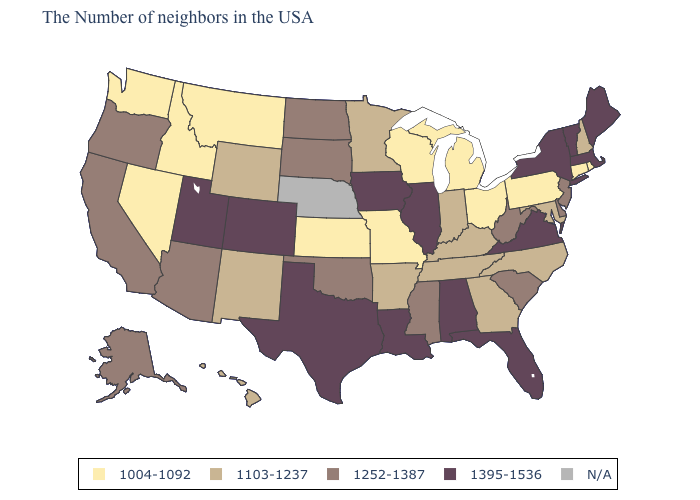What is the highest value in states that border New Jersey?
Concise answer only. 1395-1536. What is the value of Georgia?
Keep it brief. 1103-1237. What is the highest value in the USA?
Give a very brief answer. 1395-1536. What is the value of Pennsylvania?
Quick response, please. 1004-1092. What is the lowest value in states that border Tennessee?
Give a very brief answer. 1004-1092. What is the lowest value in the USA?
Write a very short answer. 1004-1092. Name the states that have a value in the range 1395-1536?
Write a very short answer. Maine, Massachusetts, Vermont, New York, Virginia, Florida, Alabama, Illinois, Louisiana, Iowa, Texas, Colorado, Utah. Which states hav the highest value in the West?
Quick response, please. Colorado, Utah. What is the value of Wyoming?
Short answer required. 1103-1237. What is the highest value in states that border Vermont?
Short answer required. 1395-1536. What is the value of Connecticut?
Give a very brief answer. 1004-1092. Name the states that have a value in the range 1103-1237?
Be succinct. New Hampshire, Maryland, North Carolina, Georgia, Kentucky, Indiana, Tennessee, Arkansas, Minnesota, Wyoming, New Mexico, Hawaii. What is the value of Mississippi?
Answer briefly. 1252-1387. Does New Hampshire have the highest value in the USA?
Concise answer only. No. 